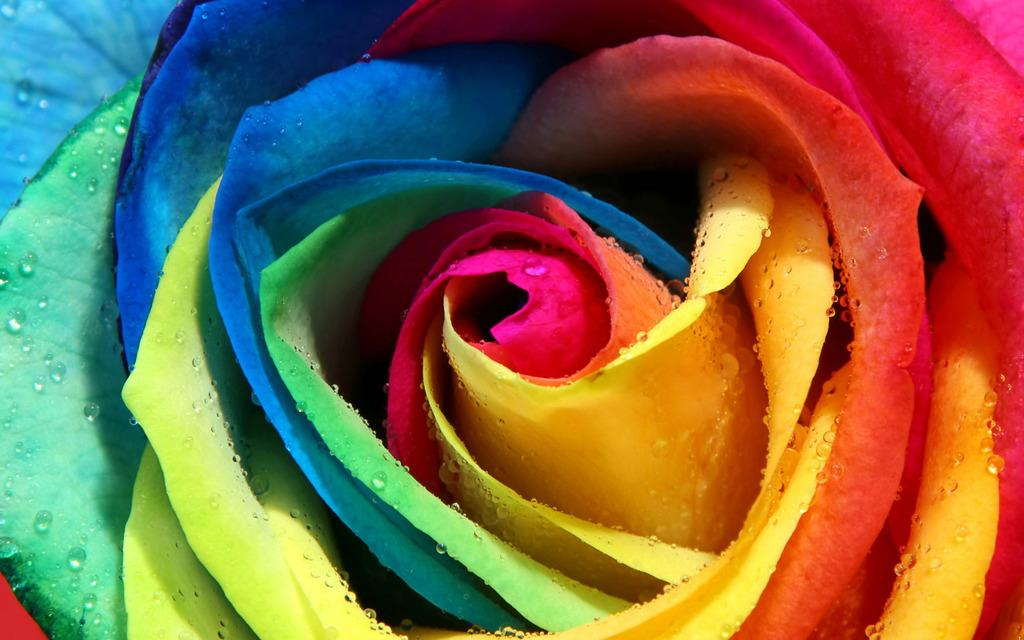What type of object is present in the image? There is a colorful flower in the image. Can you describe the appearance of the flower? The flower is colorful, but the specific colors cannot be determined from the facts provided. What might be the purpose of including this flower in the image? The purpose of including the flower in the image is not specified in the facts provided. How many goldfish are swimming in the flower in the image? There are no goldfish present in the image; it features a colorful flower. What type of government is depicted in the image? There is no reference to a government in the image, which features a colorful flower. 